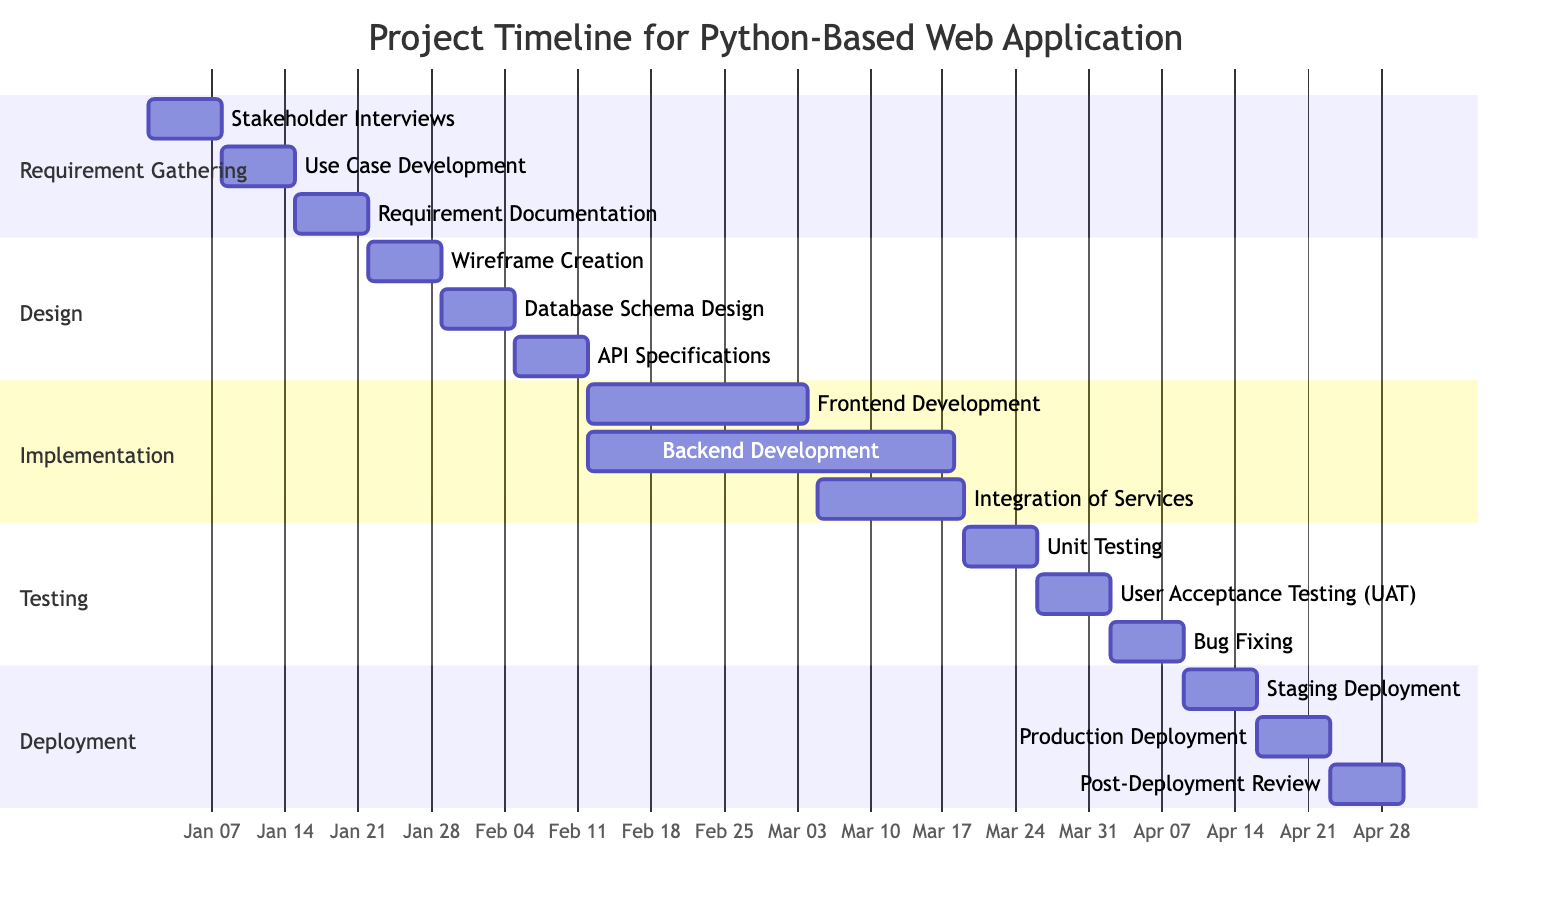What is the duration of the Requirement Gathering phase? The Requirement Gathering phase consists of three tasks running consecutively from January 1 to January 21, which is a total of 21 days.
Answer: 21 days How many tasks are there in the Testing phase? The Testing phase contains three tasks: Unit Testing, User Acceptance Testing, and Bug Fixing. Counting these gives a total of three tasks.
Answer: 3 tasks What task follows Database Schema Design? Following Database Schema Design, the next task is API Specifications, which starts on February 5.
Answer: API Specifications Which task has the longest duration in the Implementation phase? In the Implementation phase, Backend Development spans five weeks while the other tasks are shorter in duration. Therefore, it has the longest duration.
Answer: Backend Development When does the Integration of Services task start? The Integration of Services task begins on March 5, which is clearly indicated in the timeline.
Answer: March 5 What is the total number of phases in the project timeline? There are five distinct phases in the project timeline: Requirement Gathering, Design, Implementation, Testing, and Deployment, making a total of five.
Answer: 5 phases Which task begins first in the Deployment phase? Staging Deployment is the first task in the Deployment phase starting on April 9, before the Production Deployment.
Answer: Staging Deployment How long does the User Acceptance Testing (UAT) last? User Acceptance Testing (UAT) is scheduled to last one week, from March 26 to April 1.
Answer: 1 week What is the end date of the Post-Deployment Review task? The Post-Deployment Review task concludes on April 29, as specified in the timeline.
Answer: April 29 